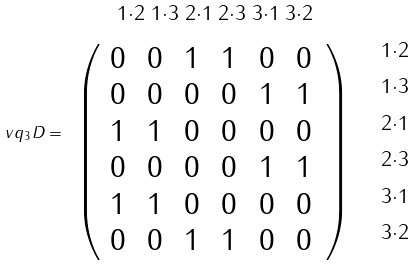<formula> <loc_0><loc_0><loc_500><loc_500>\ v q _ { 3 } D = \begin{array} { c c } \, ^ { 1 \cdot 2 } \, ^ { 1 \cdot 3 } \, ^ { 2 \cdot 1 } \, ^ { 2 \cdot 3 } \, ^ { 3 \cdot 1 } \, ^ { 3 \cdot 2 } & \\ \left ( \begin{array} { c c c c c c } 0 \, & 0 \, & 1 \, & 1 \, & 0 \, & 0 \, \\ 0 \, & 0 \, & 0 \, & 0 \, & 1 \, & 1 \, \\ 1 \, & 1 \, & 0 \, & 0 \, & 0 \, & 0 \, \\ 0 \, & 0 \, & 0 \, & 0 \, & 1 \, & 1 \, \\ 1 \, & 1 \, & 0 \, & 0 \, & 0 \, & 0 \, \\ 0 \, & 0 \, & 1 \, & 1 \, & 0 \, & 0 \, \end{array} \right ) & \begin{array} { c } \, ^ { 1 \cdot 2 } \\ \, ^ { 1 \cdot 3 } \\ \, ^ { 2 \cdot 1 } \\ \, ^ { 2 \cdot 3 } \\ \, ^ { 3 \cdot 1 } \\ \, ^ { 3 \cdot 2 } \end{array} \end{array}</formula> 